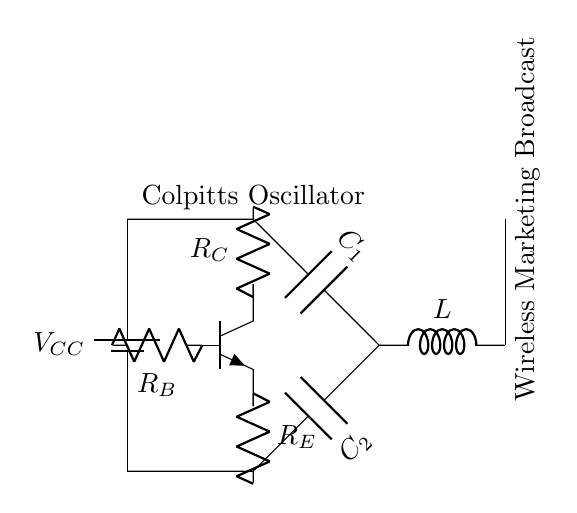What is the function of the transistor in this circuit? The transistor in the Colpitts oscillator acts as an active component that amplifies the signal, allowing it to oscillate. It provides the necessary gain for the circuit to function as an oscillator.
Answer: active component What type of oscillator is represented in the circuit? The circuit is identified as a Colpitts oscillator, which is characterized by its arrangement of inductors and capacitors to generate oscillations.
Answer: Colpitts What components constitute the resonant circuit? The resonant circuit is formed by the combination of the inductor and the two capacitors, which store energy and produce oscillations at a certain frequency.
Answer: inductor and capacitors What is the voltage supply labeled as in the circuit? The voltage supply is labeled as V subscript CC, indicating the positive supply voltage for the transistor and overall circuit operation.
Answer: V subscript CC What type of device is used to transmit the signal in this circuit? The device used to transmit the signal is an antenna, which converts the electrical oscillations into radio waves for wireless broadcasting.
Answer: antenna How many resistors are present in the circuit? The circuit contains three resistors, which are R subscript C, R subscript B, and R subscript E, each serving different purposes in biasing and stability.
Answer: three What role do the capacitors play in this oscillator circuit? The capacitors in this circuit contribute to the timing and frequency determination of the oscillation by forming part of the resonant tank circuit.
Answer: timing and frequency determination 